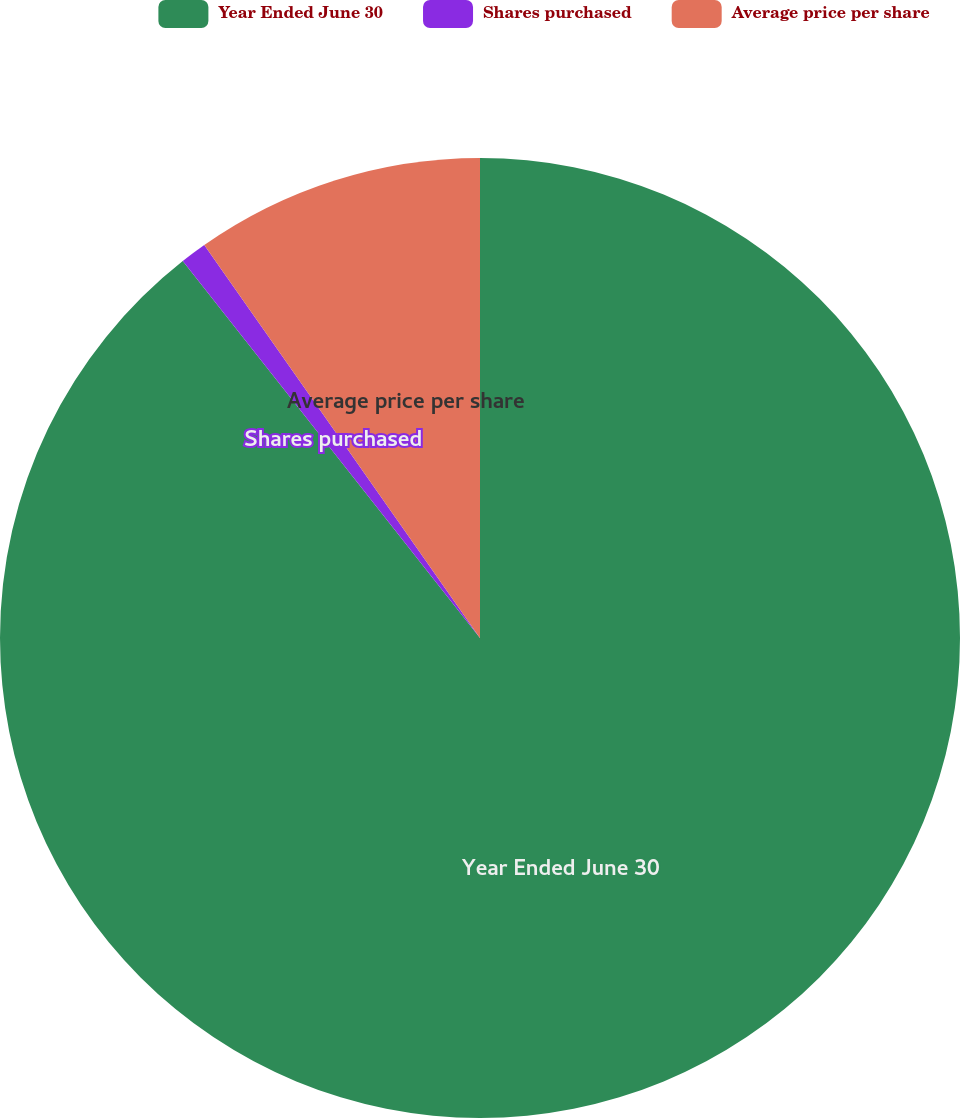<chart> <loc_0><loc_0><loc_500><loc_500><pie_chart><fcel>Year Ended June 30<fcel>Shares purchased<fcel>Average price per share<nl><fcel>89.38%<fcel>0.89%<fcel>9.74%<nl></chart> 